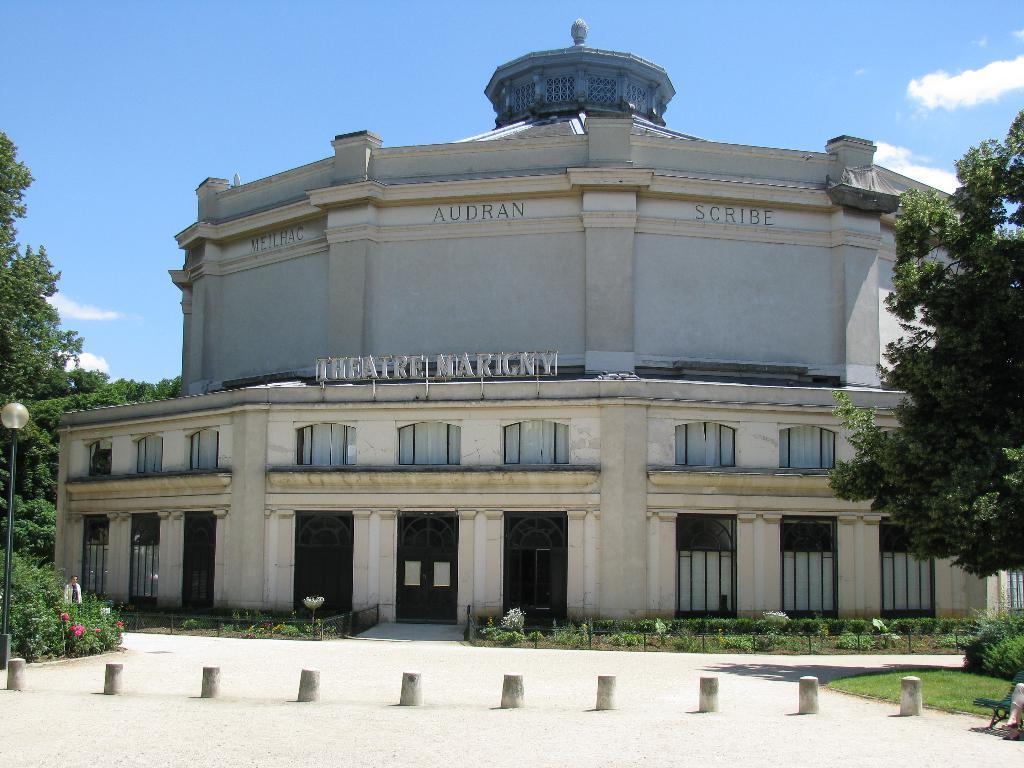In one or two sentences, can you explain what this image depicts? In this picture we can see poles on the ground and in the background we can see a building, trees, plants, flowers, person, light with a pole and the sky. 